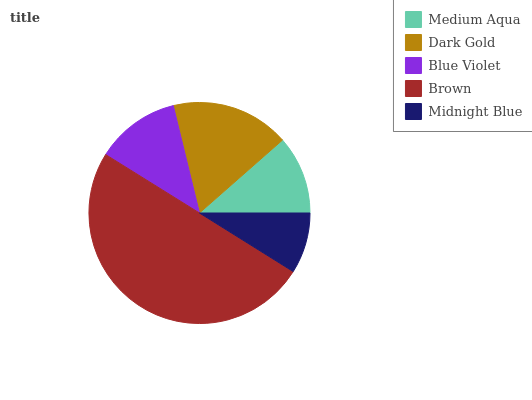Is Midnight Blue the minimum?
Answer yes or no. Yes. Is Brown the maximum?
Answer yes or no. Yes. Is Dark Gold the minimum?
Answer yes or no. No. Is Dark Gold the maximum?
Answer yes or no. No. Is Dark Gold greater than Medium Aqua?
Answer yes or no. Yes. Is Medium Aqua less than Dark Gold?
Answer yes or no. Yes. Is Medium Aqua greater than Dark Gold?
Answer yes or no. No. Is Dark Gold less than Medium Aqua?
Answer yes or no. No. Is Blue Violet the high median?
Answer yes or no. Yes. Is Blue Violet the low median?
Answer yes or no. Yes. Is Dark Gold the high median?
Answer yes or no. No. Is Midnight Blue the low median?
Answer yes or no. No. 